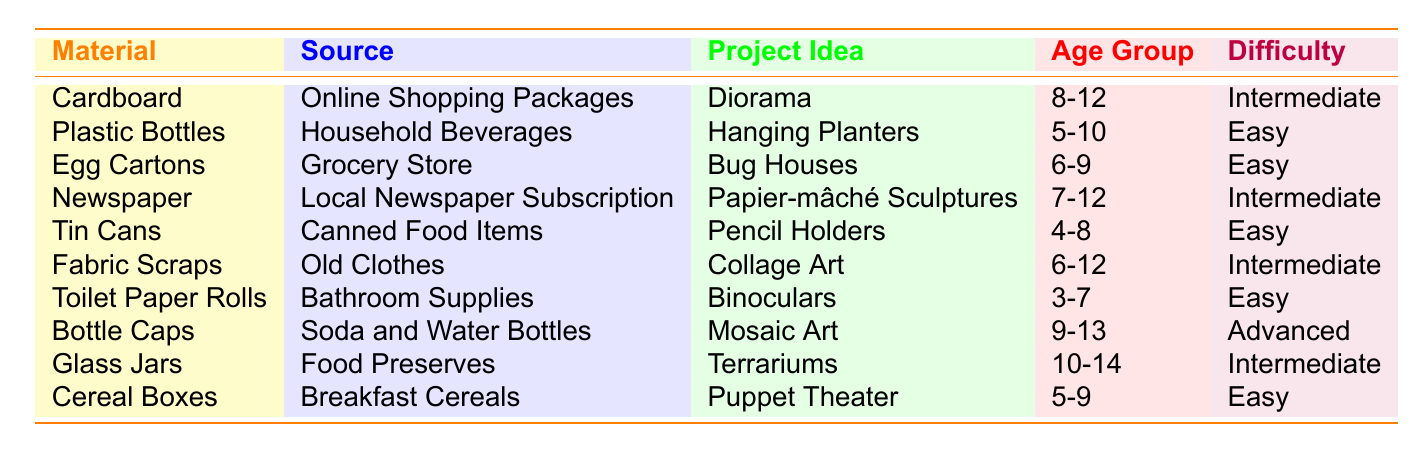What recycled material can be used to create Hanging Planters? The table shows that Hanging Planters can be made from Plastic Bottles.
Answer: Plastic Bottles Which project idea is suitable for children aged 6-9? From the table, the suitable project ideas for the age group 6-9 are Bug Houses, which can be made using Egg Cartons.
Answer: Bug Houses What is the difficulty level of creating a Diorama from cardboard? The table indicates that the difficulty level for making a Diorama from cardboard is Intermediate.
Answer: Intermediate Can Glass Jars be used to create Terrariums? Yes, according to the table, Glass Jars can indeed be used to create Terrariums.
Answer: Yes Which art project can be made with Fabric Scraps, and what is its difficulty level? The table indicates that Fabric Scraps are used for Collage Art, and the corresponding difficulty level is Intermediate.
Answer: Collage Art, Intermediate How many project ideas in the table are considered "Easy"? By examining the table, we find that six project ideas are labeled as "Easy," which are Hanging Planters, Bug Houses, Pencil Holders, Binoculars, Mosaic Art, and Puppet Theater.
Answer: 6 Is it possible to create a Puppet Theater from Cereal Boxes, and if so, what is the age group and difficulty level? Yes, Puppet Theater can be made from Cereal Boxes, it’s suitable for the age group 5-9, and its difficulty level is Easy.
Answer: Yes, 5-9, Easy What is the age range for the project idea of Mosaic Art? According to the table, Mosaic Art, which uses Bottle Caps, is suitable for the age group 9-13.
Answer: 9-13 Which material has the highest difficulty level for the project idea listed? The table indicates Bottle Caps for Mosaic Art has the highest difficulty level of Advanced among other materials and project ideas.
Answer: Advanced If a child wants to create a difficult project using a recycled item, which materials and project ideas should they consider? Based on the table, they should consider Bottle Caps for Mosaic Art (Advanced) or Cardboard for Diorama (Intermediate) as their project ideas.
Answer: Bottle Caps for Mosaic Art, Cardboard for Diorama 